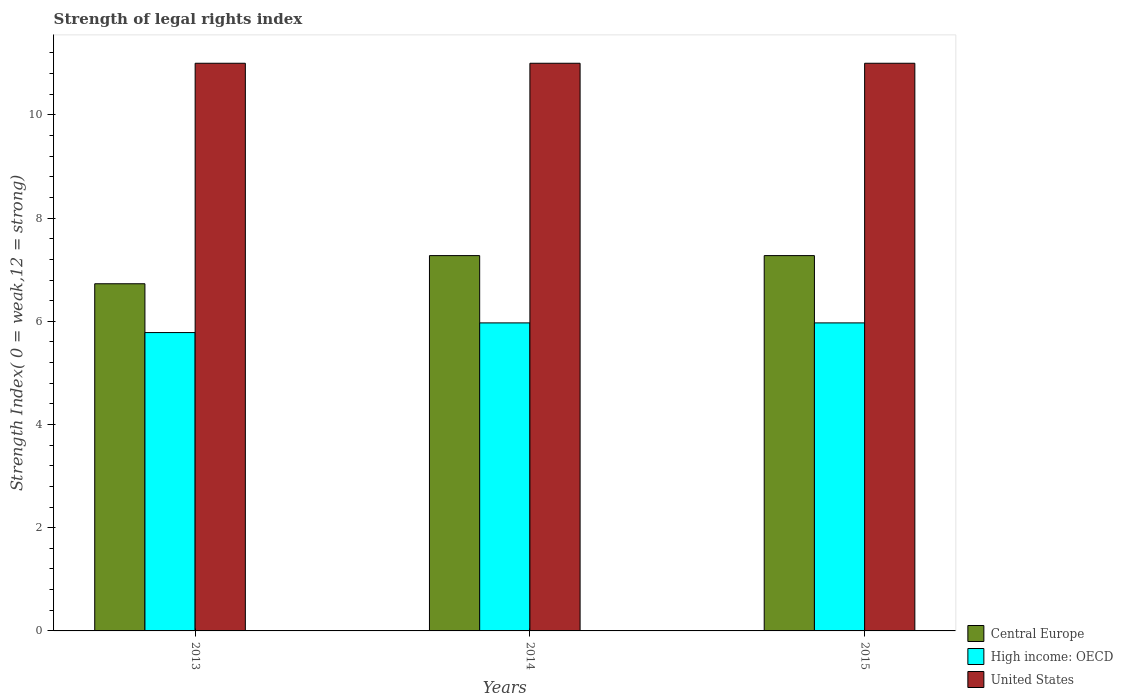How many different coloured bars are there?
Offer a terse response. 3. How many groups of bars are there?
Your response must be concise. 3. Are the number of bars on each tick of the X-axis equal?
Your answer should be very brief. Yes. How many bars are there on the 1st tick from the left?
Provide a short and direct response. 3. What is the label of the 2nd group of bars from the left?
Offer a terse response. 2014. In how many cases, is the number of bars for a given year not equal to the number of legend labels?
Provide a succinct answer. 0. What is the strength index in High income: OECD in 2014?
Your answer should be compact. 5.97. Across all years, what is the maximum strength index in Central Europe?
Give a very brief answer. 7.27. Across all years, what is the minimum strength index in United States?
Ensure brevity in your answer.  11. In which year was the strength index in Central Europe maximum?
Provide a succinct answer. 2014. In which year was the strength index in Central Europe minimum?
Provide a succinct answer. 2013. What is the total strength index in United States in the graph?
Your answer should be compact. 33. What is the difference between the strength index in Central Europe in 2015 and the strength index in High income: OECD in 2013?
Your answer should be very brief. 1.49. What is the average strength index in United States per year?
Ensure brevity in your answer.  11. In the year 2014, what is the difference between the strength index in United States and strength index in High income: OECD?
Provide a succinct answer. 5.03. In how many years, is the strength index in United States greater than 5.6?
Give a very brief answer. 3. What is the ratio of the strength index in High income: OECD in 2013 to that in 2014?
Provide a short and direct response. 0.97. Is the strength index in High income: OECD in 2013 less than that in 2014?
Keep it short and to the point. Yes. What is the difference between the highest and the second highest strength index in High income: OECD?
Your answer should be compact. 0. What does the 3rd bar from the left in 2013 represents?
Offer a very short reply. United States. What does the 1st bar from the right in 2014 represents?
Give a very brief answer. United States. Are all the bars in the graph horizontal?
Make the answer very short. No. What is the difference between two consecutive major ticks on the Y-axis?
Your answer should be compact. 2. Does the graph contain any zero values?
Your answer should be compact. No. Does the graph contain grids?
Keep it short and to the point. No. Where does the legend appear in the graph?
Your answer should be compact. Bottom right. What is the title of the graph?
Provide a short and direct response. Strength of legal rights index. Does "Trinidad and Tobago" appear as one of the legend labels in the graph?
Your answer should be compact. No. What is the label or title of the X-axis?
Keep it short and to the point. Years. What is the label or title of the Y-axis?
Keep it short and to the point. Strength Index( 0 = weak,12 = strong). What is the Strength Index( 0 = weak,12 = strong) in Central Europe in 2013?
Your response must be concise. 6.73. What is the Strength Index( 0 = weak,12 = strong) in High income: OECD in 2013?
Your response must be concise. 5.78. What is the Strength Index( 0 = weak,12 = strong) of Central Europe in 2014?
Offer a terse response. 7.27. What is the Strength Index( 0 = weak,12 = strong) of High income: OECD in 2014?
Ensure brevity in your answer.  5.97. What is the Strength Index( 0 = weak,12 = strong) of Central Europe in 2015?
Provide a short and direct response. 7.27. What is the Strength Index( 0 = weak,12 = strong) of High income: OECD in 2015?
Your answer should be compact. 5.97. Across all years, what is the maximum Strength Index( 0 = weak,12 = strong) in Central Europe?
Your response must be concise. 7.27. Across all years, what is the maximum Strength Index( 0 = weak,12 = strong) in High income: OECD?
Offer a terse response. 5.97. Across all years, what is the maximum Strength Index( 0 = weak,12 = strong) in United States?
Your answer should be very brief. 11. Across all years, what is the minimum Strength Index( 0 = weak,12 = strong) of Central Europe?
Provide a short and direct response. 6.73. Across all years, what is the minimum Strength Index( 0 = weak,12 = strong) of High income: OECD?
Your answer should be compact. 5.78. Across all years, what is the minimum Strength Index( 0 = weak,12 = strong) in United States?
Offer a very short reply. 11. What is the total Strength Index( 0 = weak,12 = strong) in Central Europe in the graph?
Ensure brevity in your answer.  21.27. What is the total Strength Index( 0 = weak,12 = strong) in High income: OECD in the graph?
Provide a succinct answer. 17.72. What is the difference between the Strength Index( 0 = weak,12 = strong) of Central Europe in 2013 and that in 2014?
Provide a short and direct response. -0.55. What is the difference between the Strength Index( 0 = weak,12 = strong) of High income: OECD in 2013 and that in 2014?
Keep it short and to the point. -0.19. What is the difference between the Strength Index( 0 = weak,12 = strong) in United States in 2013 and that in 2014?
Give a very brief answer. 0. What is the difference between the Strength Index( 0 = weak,12 = strong) of Central Europe in 2013 and that in 2015?
Offer a very short reply. -0.55. What is the difference between the Strength Index( 0 = weak,12 = strong) of High income: OECD in 2013 and that in 2015?
Your answer should be compact. -0.19. What is the difference between the Strength Index( 0 = weak,12 = strong) in Central Europe in 2014 and that in 2015?
Make the answer very short. 0. What is the difference between the Strength Index( 0 = weak,12 = strong) in High income: OECD in 2014 and that in 2015?
Keep it short and to the point. 0. What is the difference between the Strength Index( 0 = weak,12 = strong) of Central Europe in 2013 and the Strength Index( 0 = weak,12 = strong) of High income: OECD in 2014?
Give a very brief answer. 0.76. What is the difference between the Strength Index( 0 = weak,12 = strong) of Central Europe in 2013 and the Strength Index( 0 = weak,12 = strong) of United States in 2014?
Ensure brevity in your answer.  -4.27. What is the difference between the Strength Index( 0 = weak,12 = strong) of High income: OECD in 2013 and the Strength Index( 0 = weak,12 = strong) of United States in 2014?
Give a very brief answer. -5.22. What is the difference between the Strength Index( 0 = weak,12 = strong) of Central Europe in 2013 and the Strength Index( 0 = weak,12 = strong) of High income: OECD in 2015?
Your response must be concise. 0.76. What is the difference between the Strength Index( 0 = weak,12 = strong) in Central Europe in 2013 and the Strength Index( 0 = weak,12 = strong) in United States in 2015?
Your answer should be very brief. -4.27. What is the difference between the Strength Index( 0 = weak,12 = strong) of High income: OECD in 2013 and the Strength Index( 0 = weak,12 = strong) of United States in 2015?
Give a very brief answer. -5.22. What is the difference between the Strength Index( 0 = weak,12 = strong) in Central Europe in 2014 and the Strength Index( 0 = weak,12 = strong) in High income: OECD in 2015?
Your answer should be compact. 1.3. What is the difference between the Strength Index( 0 = weak,12 = strong) in Central Europe in 2014 and the Strength Index( 0 = weak,12 = strong) in United States in 2015?
Offer a very short reply. -3.73. What is the difference between the Strength Index( 0 = weak,12 = strong) in High income: OECD in 2014 and the Strength Index( 0 = weak,12 = strong) in United States in 2015?
Your answer should be very brief. -5.03. What is the average Strength Index( 0 = weak,12 = strong) in Central Europe per year?
Offer a terse response. 7.09. What is the average Strength Index( 0 = weak,12 = strong) in High income: OECD per year?
Ensure brevity in your answer.  5.91. In the year 2013, what is the difference between the Strength Index( 0 = weak,12 = strong) of Central Europe and Strength Index( 0 = weak,12 = strong) of High income: OECD?
Make the answer very short. 0.95. In the year 2013, what is the difference between the Strength Index( 0 = weak,12 = strong) of Central Europe and Strength Index( 0 = weak,12 = strong) of United States?
Make the answer very short. -4.27. In the year 2013, what is the difference between the Strength Index( 0 = weak,12 = strong) of High income: OECD and Strength Index( 0 = weak,12 = strong) of United States?
Provide a succinct answer. -5.22. In the year 2014, what is the difference between the Strength Index( 0 = weak,12 = strong) in Central Europe and Strength Index( 0 = weak,12 = strong) in High income: OECD?
Offer a terse response. 1.3. In the year 2014, what is the difference between the Strength Index( 0 = weak,12 = strong) of Central Europe and Strength Index( 0 = weak,12 = strong) of United States?
Make the answer very short. -3.73. In the year 2014, what is the difference between the Strength Index( 0 = weak,12 = strong) in High income: OECD and Strength Index( 0 = weak,12 = strong) in United States?
Ensure brevity in your answer.  -5.03. In the year 2015, what is the difference between the Strength Index( 0 = weak,12 = strong) in Central Europe and Strength Index( 0 = weak,12 = strong) in High income: OECD?
Give a very brief answer. 1.3. In the year 2015, what is the difference between the Strength Index( 0 = weak,12 = strong) in Central Europe and Strength Index( 0 = weak,12 = strong) in United States?
Make the answer very short. -3.73. In the year 2015, what is the difference between the Strength Index( 0 = weak,12 = strong) of High income: OECD and Strength Index( 0 = weak,12 = strong) of United States?
Provide a short and direct response. -5.03. What is the ratio of the Strength Index( 0 = weak,12 = strong) in Central Europe in 2013 to that in 2014?
Give a very brief answer. 0.93. What is the ratio of the Strength Index( 0 = weak,12 = strong) of High income: OECD in 2013 to that in 2014?
Offer a terse response. 0.97. What is the ratio of the Strength Index( 0 = weak,12 = strong) of United States in 2013 to that in 2014?
Keep it short and to the point. 1. What is the ratio of the Strength Index( 0 = weak,12 = strong) in Central Europe in 2013 to that in 2015?
Provide a short and direct response. 0.93. What is the ratio of the Strength Index( 0 = weak,12 = strong) in High income: OECD in 2013 to that in 2015?
Keep it short and to the point. 0.97. What is the ratio of the Strength Index( 0 = weak,12 = strong) in United States in 2014 to that in 2015?
Provide a succinct answer. 1. What is the difference between the highest and the second highest Strength Index( 0 = weak,12 = strong) of Central Europe?
Give a very brief answer. 0. What is the difference between the highest and the second highest Strength Index( 0 = weak,12 = strong) of High income: OECD?
Keep it short and to the point. 0. What is the difference between the highest and the lowest Strength Index( 0 = weak,12 = strong) of Central Europe?
Your response must be concise. 0.55. What is the difference between the highest and the lowest Strength Index( 0 = weak,12 = strong) of High income: OECD?
Your answer should be compact. 0.19. 